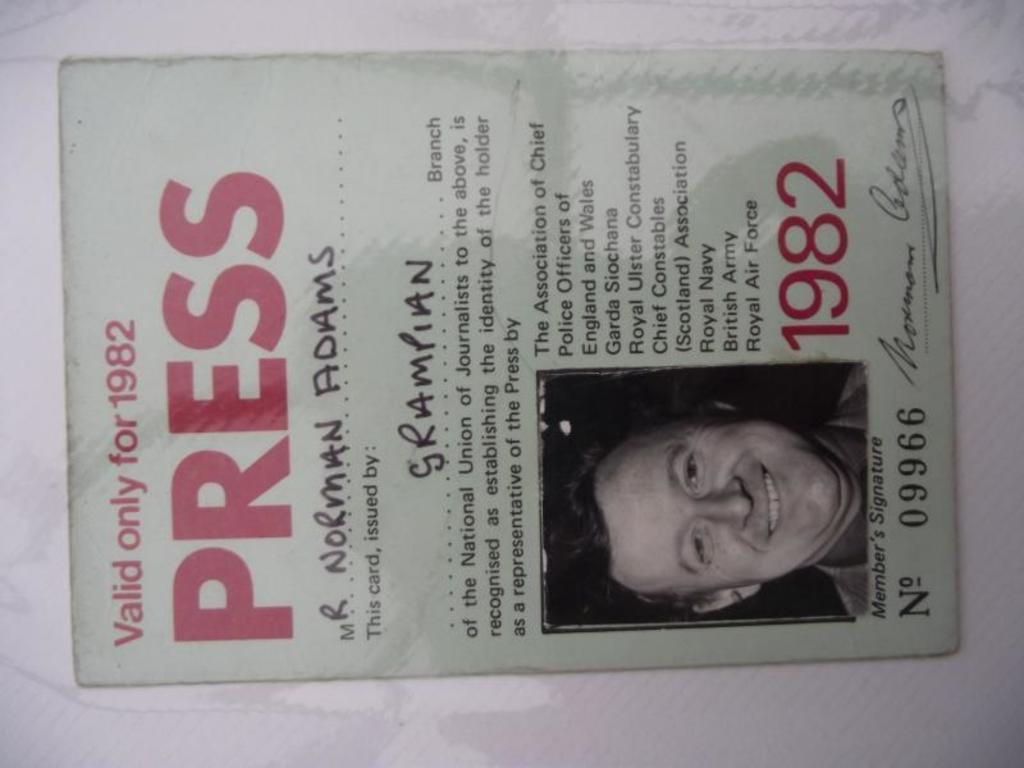What is present in the image that features a design or message? There is a poster in the image. Where is the poster located in the image? The poster is on a surface. What can be seen on the poster? There is a person depicted on the poster. What else is featured on the poster besides the image? There is text present on the poster. Can you see any seashore depicted on the poster? There is no seashore depicted on the poster; it features a person. What type of glue is used to attach the poster to the surface? There is no information about the type of glue used to attach the poster to the surface. 